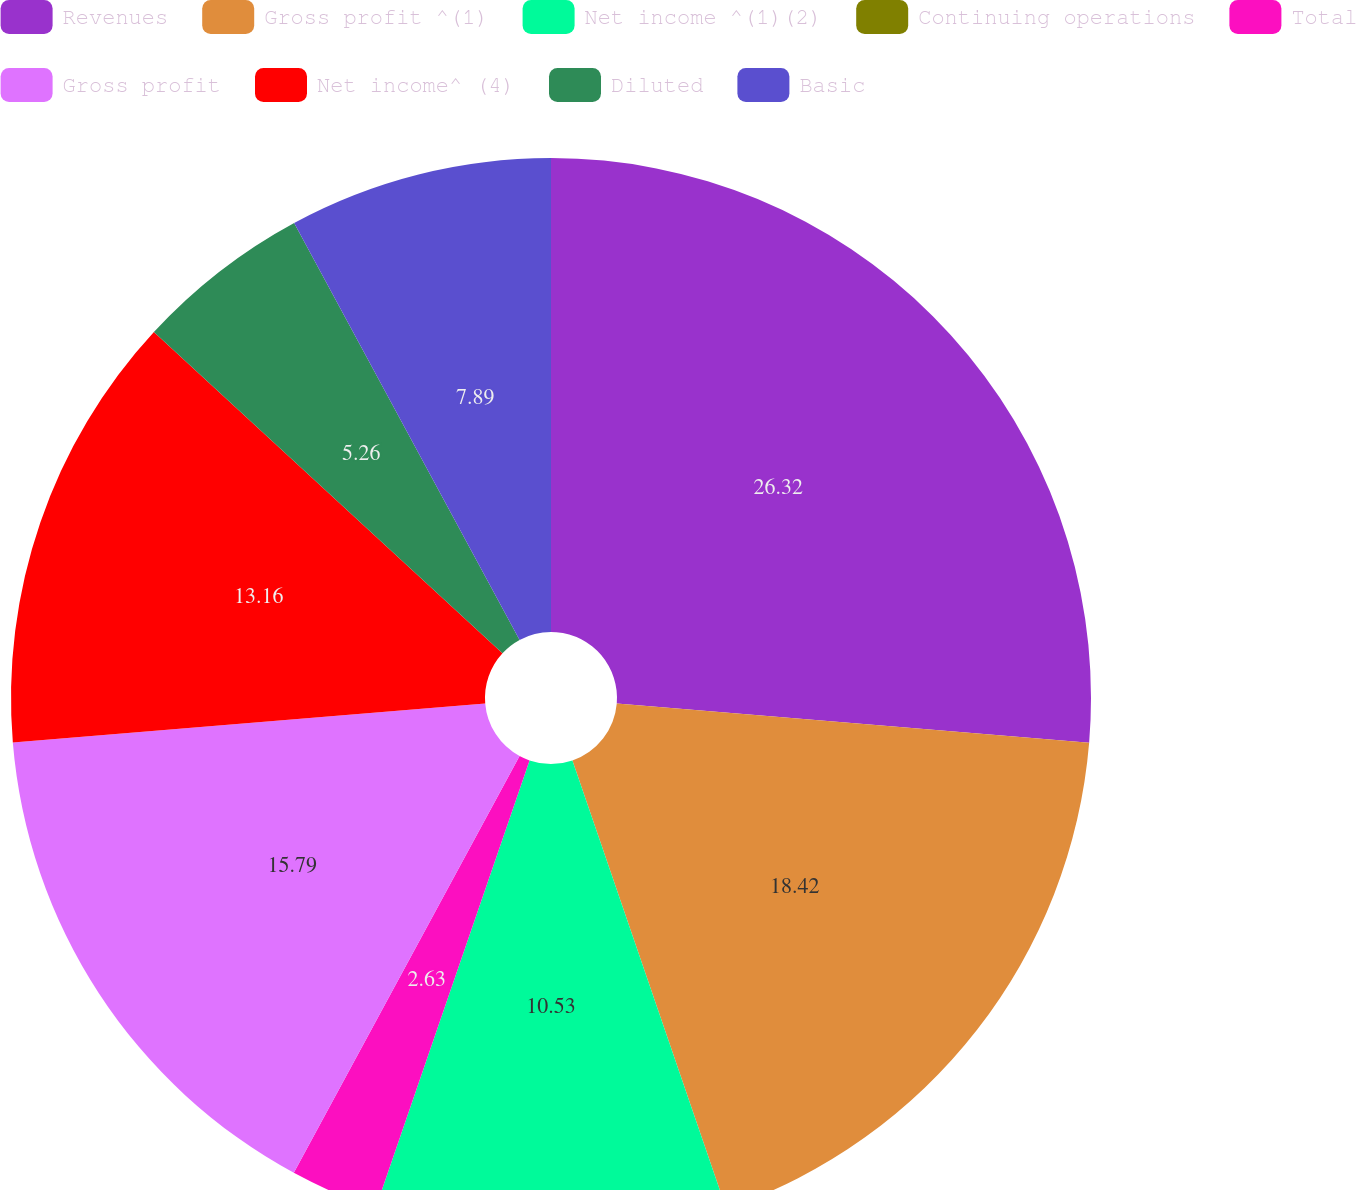<chart> <loc_0><loc_0><loc_500><loc_500><pie_chart><fcel>Revenues<fcel>Gross profit ^(1)<fcel>Net income ^(1)(2)<fcel>Continuing operations<fcel>Total<fcel>Gross profit<fcel>Net income^ (4)<fcel>Diluted<fcel>Basic<nl><fcel>26.32%<fcel>18.42%<fcel>10.53%<fcel>0.0%<fcel>2.63%<fcel>15.79%<fcel>13.16%<fcel>5.26%<fcel>7.89%<nl></chart> 